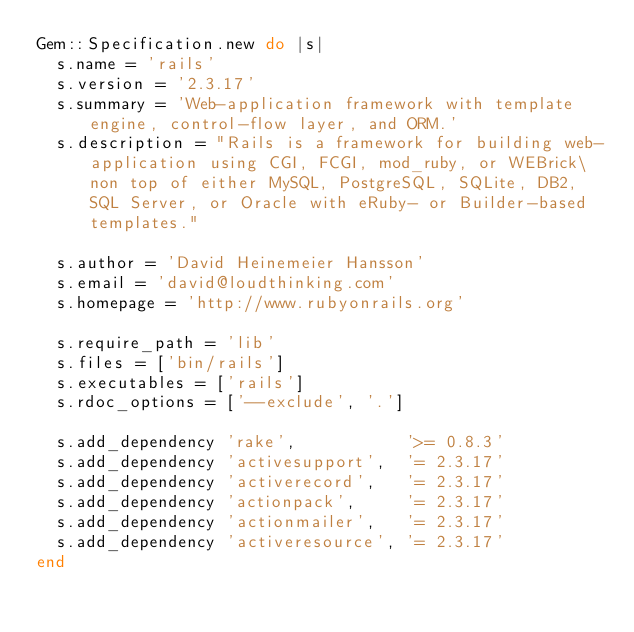<code> <loc_0><loc_0><loc_500><loc_500><_Ruby_>Gem::Specification.new do |s|
  s.name = 'rails'
  s.version = '2.3.17'
  s.summary = 'Web-application framework with template engine, control-flow layer, and ORM.'
  s.description = "Rails is a framework for building web-application using CGI, FCGI, mod_ruby, or WEBrick\non top of either MySQL, PostgreSQL, SQLite, DB2, SQL Server, or Oracle with eRuby- or Builder-based templates."

  s.author = 'David Heinemeier Hansson'
  s.email = 'david@loudthinking.com'
  s.homepage = 'http://www.rubyonrails.org'

  s.require_path = 'lib'
  s.files = ['bin/rails']
  s.executables = ['rails']
  s.rdoc_options = ['--exclude', '.']

  s.add_dependency 'rake',           '>= 0.8.3'
  s.add_dependency 'activesupport',  '= 2.3.17'
  s.add_dependency 'activerecord',   '= 2.3.17'
  s.add_dependency 'actionpack',     '= 2.3.17'
  s.add_dependency 'actionmailer',   '= 2.3.17'
  s.add_dependency 'activeresource', '= 2.3.17'
end
</code> 